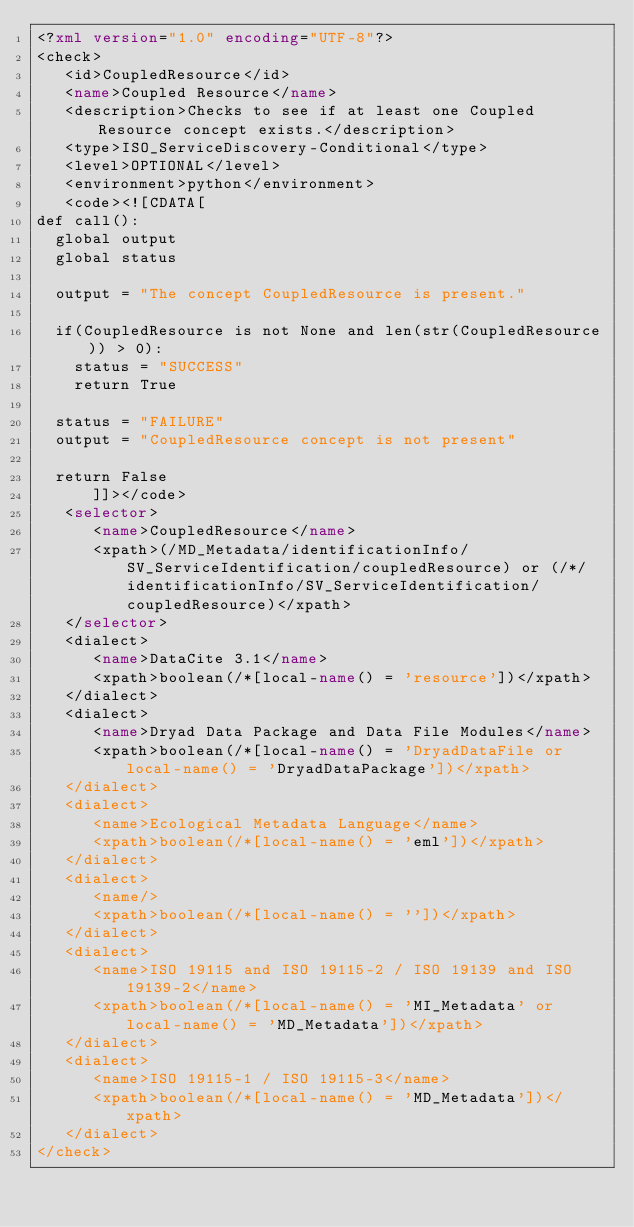Convert code to text. <code><loc_0><loc_0><loc_500><loc_500><_XML_><?xml version="1.0" encoding="UTF-8"?>
<check>
   <id>CoupledResource</id>
   <name>Coupled Resource</name>
   <description>Checks to see if at least one Coupled Resource concept exists.</description>
   <type>ISO_ServiceDiscovery-Conditional</type>
   <level>OPTIONAL</level>
   <environment>python</environment>
   <code><![CDATA[
def call():
  global output
  global status
 
  output = "The concept CoupledResource is present."
                                        
  if(CoupledResource is not None and len(str(CoupledResource)) > 0):
    status = "SUCCESS"
    return True
    
  status = "FAILURE"
  output = "CoupledResource concept is not present"
  
  return False
      ]]></code>
   <selector>
      <name>CoupledResource</name>
      <xpath>(/MD_Metadata/identificationInfo/SV_ServiceIdentification/coupledResource) or (/*/identificationInfo/SV_ServiceIdentification/coupledResource)</xpath>
   </selector>
   <dialect>
      <name>DataCite 3.1</name>
      <xpath>boolean(/*[local-name() = 'resource'])</xpath>
   </dialect>
   <dialect>
      <name>Dryad Data Package and Data File Modules</name>
      <xpath>boolean(/*[local-name() = 'DryadDataFile or local-name() = 'DryadDataPackage'])</xpath>
   </dialect>
   <dialect>
      <name>Ecological Metadata Language</name>
      <xpath>boolean(/*[local-name() = 'eml'])</xpath>
   </dialect>
   <dialect>
      <name/>
      <xpath>boolean(/*[local-name() = ''])</xpath>
   </dialect>
   <dialect>
      <name>ISO 19115 and ISO 19115-2 / ISO 19139 and ISO 19139-2</name>
      <xpath>boolean(/*[local-name() = 'MI_Metadata' or local-name() = 'MD_Metadata'])</xpath>
   </dialect>
   <dialect>
      <name>ISO 19115-1 / ISO 19115-3</name>
      <xpath>boolean(/*[local-name() = 'MD_Metadata'])</xpath>
   </dialect>
</check>
</code> 